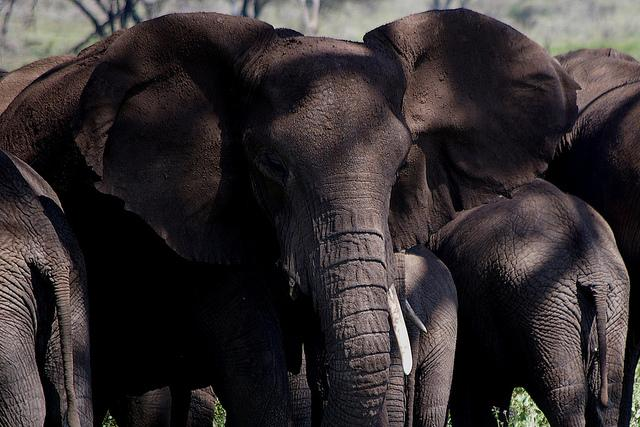What type of elephant is in the image? Please explain your reasoning. adult. A grown elephant is there. 